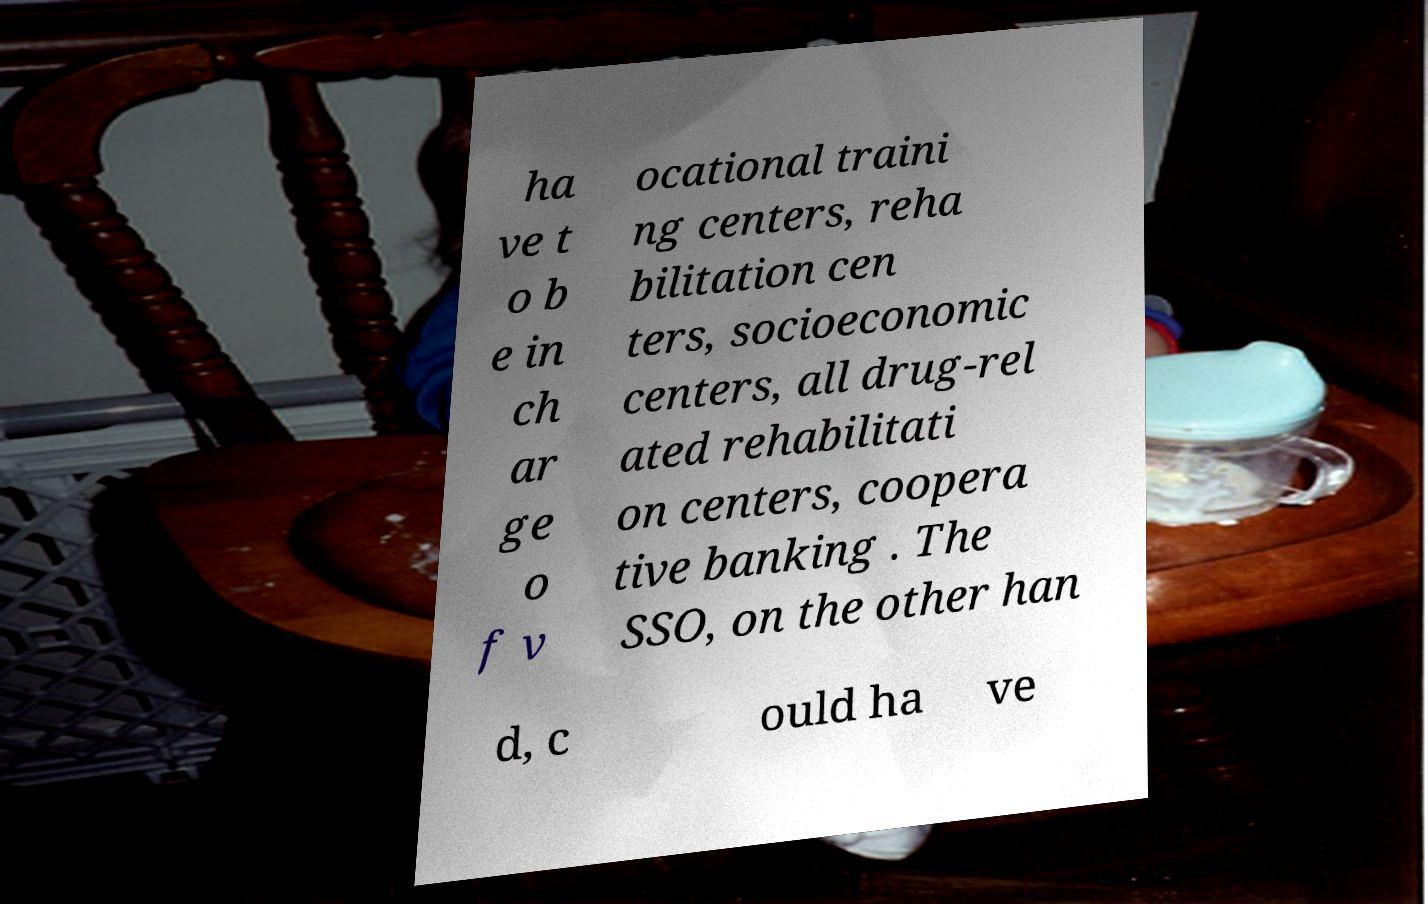Can you read and provide the text displayed in the image?This photo seems to have some interesting text. Can you extract and type it out for me? ha ve t o b e in ch ar ge o f v ocational traini ng centers, reha bilitation cen ters, socioeconomic centers, all drug-rel ated rehabilitati on centers, coopera tive banking . The SSO, on the other han d, c ould ha ve 